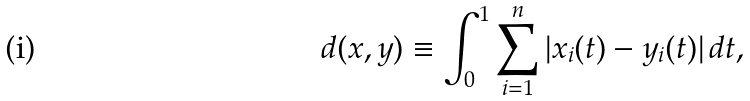Convert formula to latex. <formula><loc_0><loc_0><loc_500><loc_500>d ( { x } , { y } ) \equiv \int _ { 0 } ^ { 1 } \sum _ { i = 1 } ^ { n } | x _ { i } ( t ) - y _ { i } ( t ) | \, d t ,</formula> 